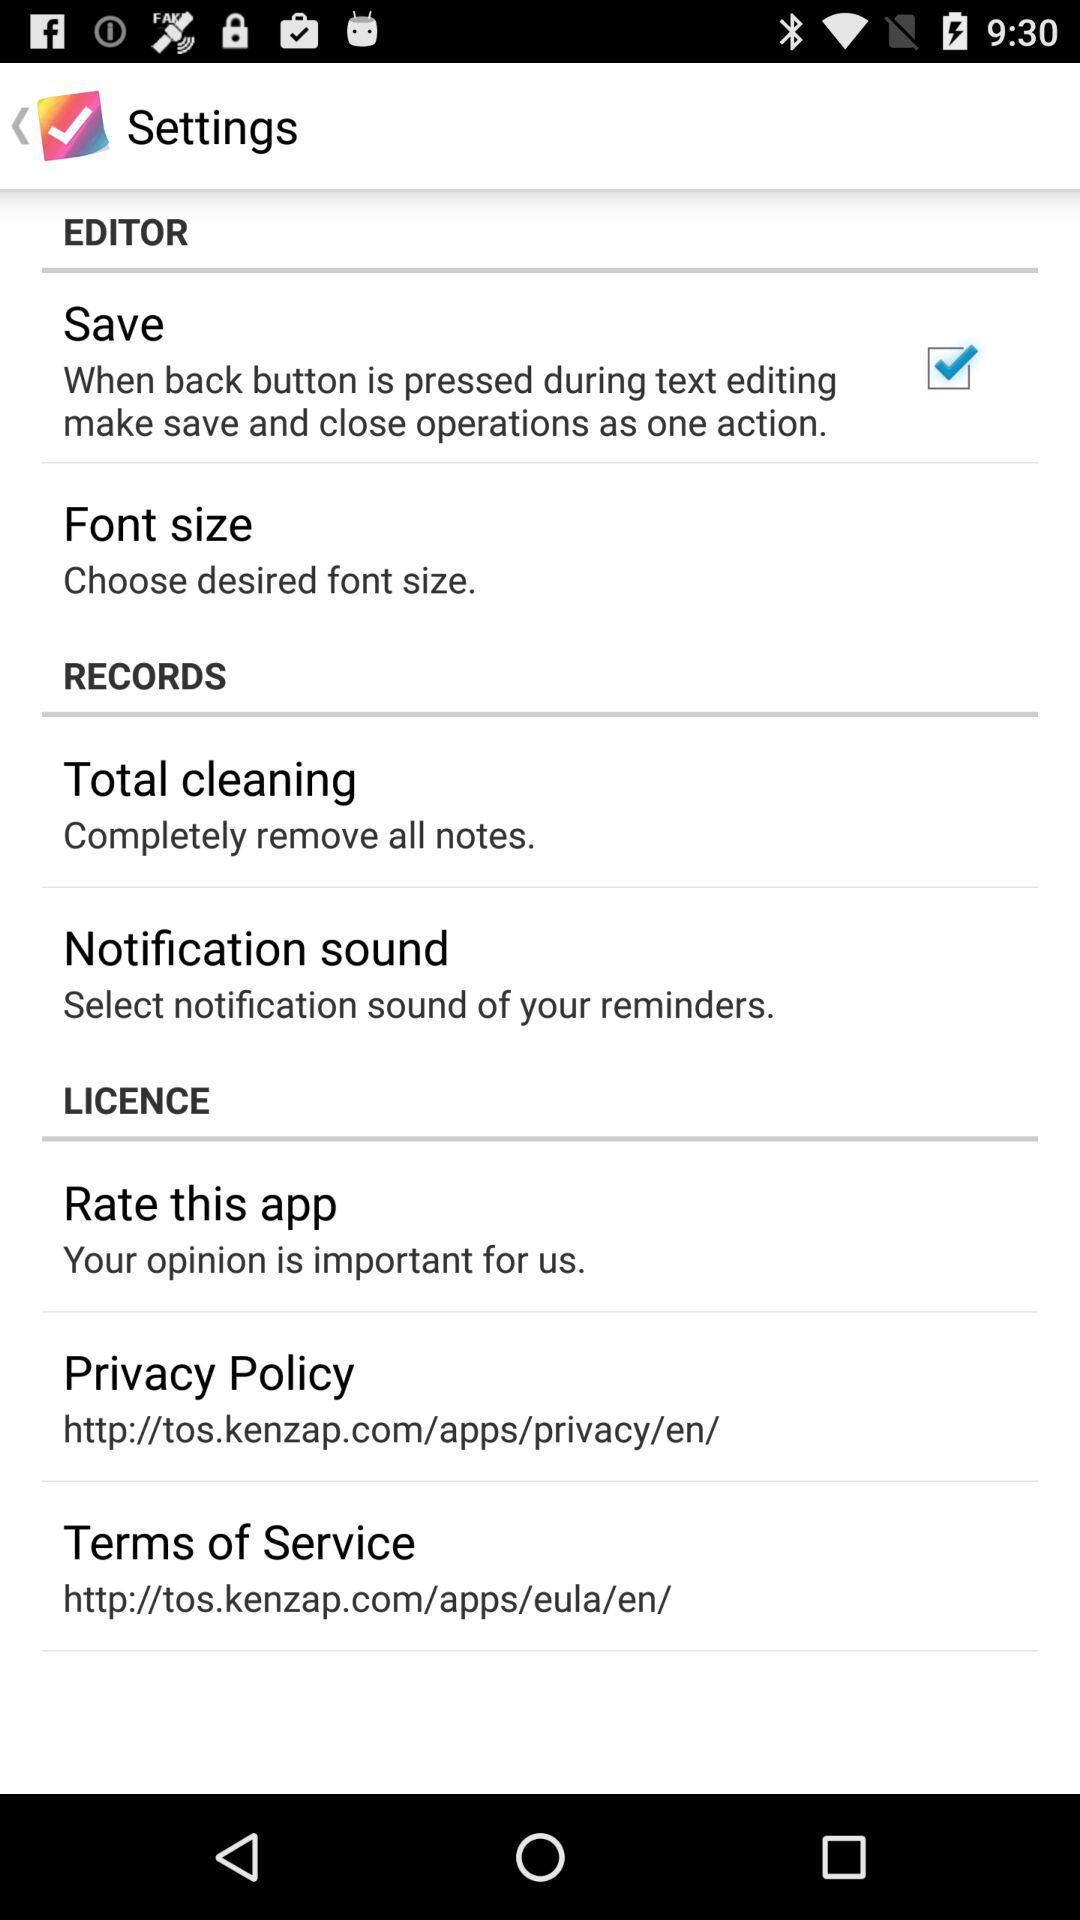What checkbox is checked? The checked checkbox is "Save". 